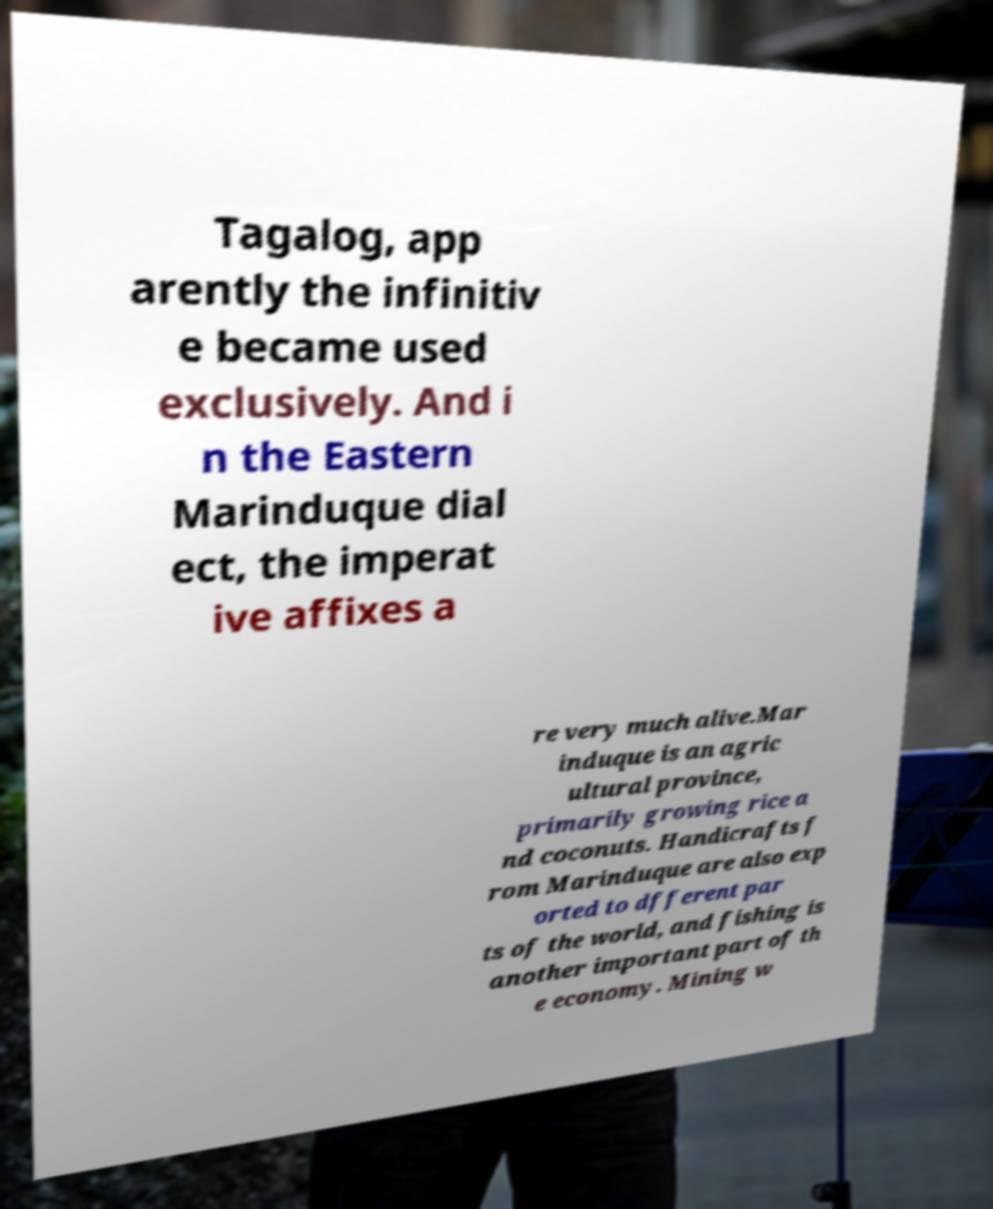Could you assist in decoding the text presented in this image and type it out clearly? Tagalog, app arently the infinitiv e became used exclusively. And i n the Eastern Marinduque dial ect, the imperat ive affixes a re very much alive.Mar induque is an agric ultural province, primarily growing rice a nd coconuts. Handicrafts f rom Marinduque are also exp orted to dfferent par ts of the world, and fishing is another important part of th e economy. Mining w 